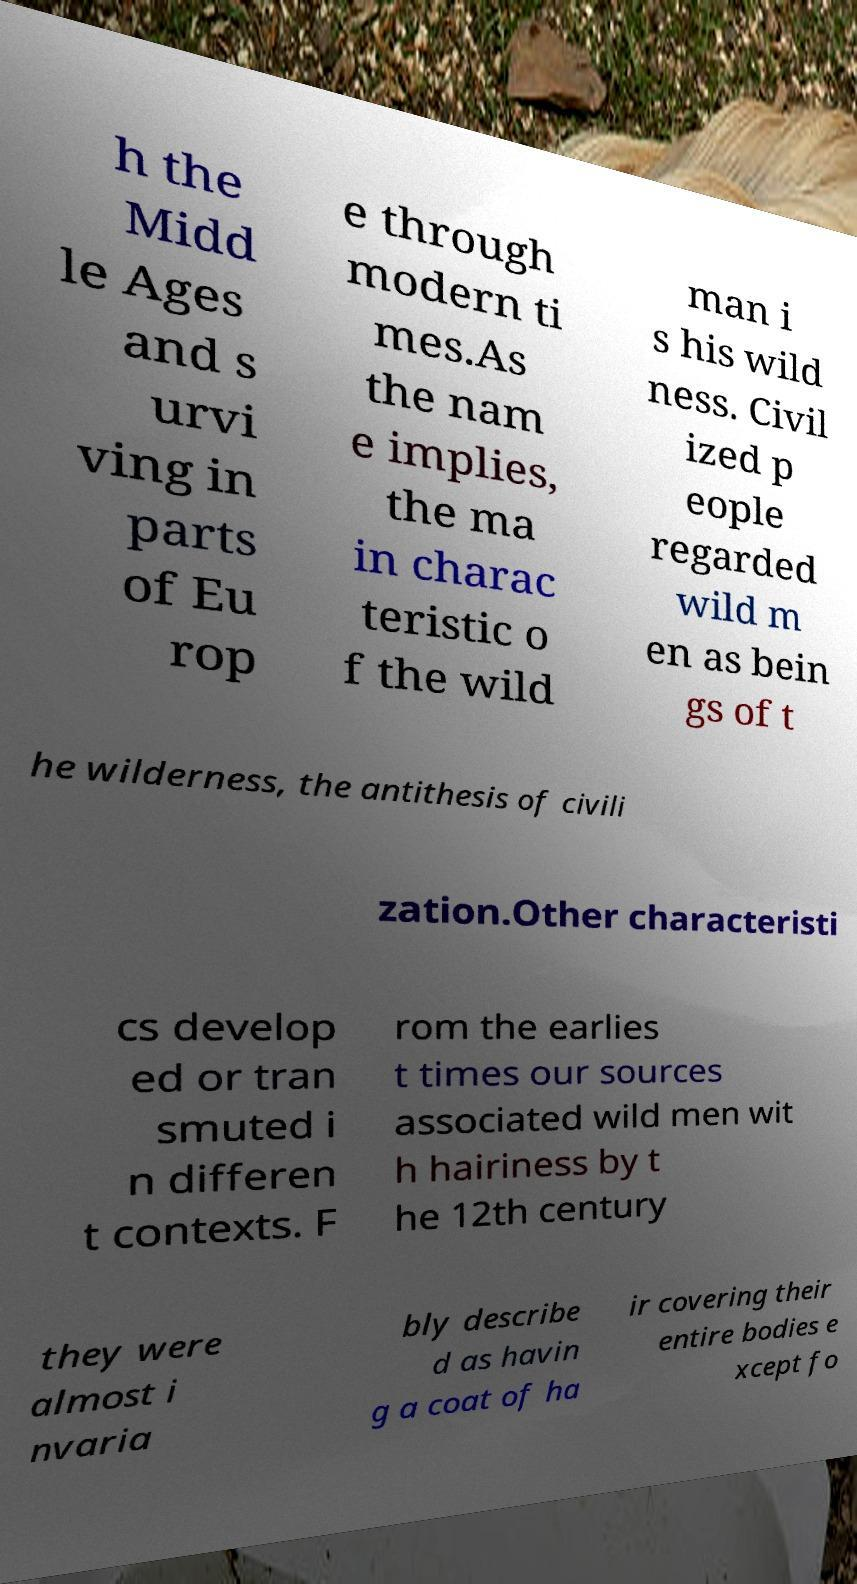For documentation purposes, I need the text within this image transcribed. Could you provide that? h the Midd le Ages and s urvi ving in parts of Eu rop e through modern ti mes.As the nam e implies, the ma in charac teristic o f the wild man i s his wild ness. Civil ized p eople regarded wild m en as bein gs of t he wilderness, the antithesis of civili zation.Other characteristi cs develop ed or tran smuted i n differen t contexts. F rom the earlies t times our sources associated wild men wit h hairiness by t he 12th century they were almost i nvaria bly describe d as havin g a coat of ha ir covering their entire bodies e xcept fo 